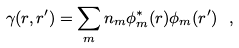<formula> <loc_0><loc_0><loc_500><loc_500>\gamma ( r , r ^ { \prime } ) = \sum _ { m } n _ { m } \phi _ { m } ^ { * } ( r ) \phi _ { m } ( r ^ { \prime } ) \ ,</formula> 